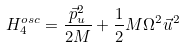Convert formula to latex. <formula><loc_0><loc_0><loc_500><loc_500>H _ { 4 } ^ { o s c } = \frac { \vec { p } ^ { 2 } _ { u } } { 2 M } + \frac { 1 } { 2 } M \Omega ^ { 2 } \vec { u } ^ { 2 }</formula> 